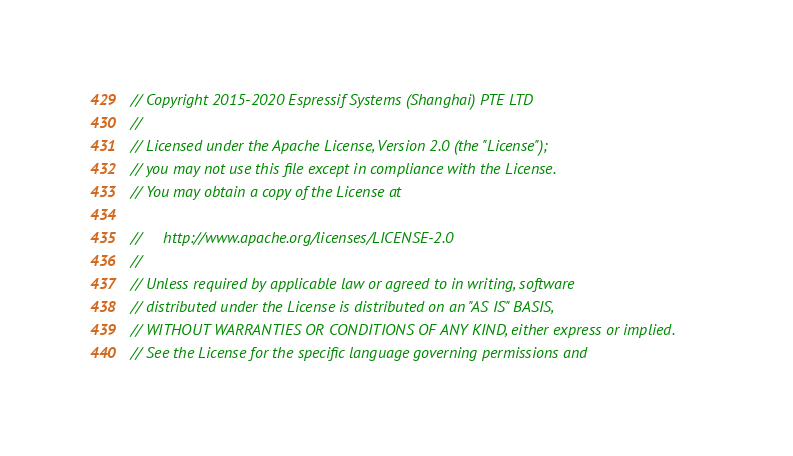Convert code to text. <code><loc_0><loc_0><loc_500><loc_500><_C_>// Copyright 2015-2020 Espressif Systems (Shanghai) PTE LTD
//
// Licensed under the Apache License, Version 2.0 (the "License");
// you may not use this file except in compliance with the License.
// You may obtain a copy of the License at

//     http://www.apache.org/licenses/LICENSE-2.0
//
// Unless required by applicable law or agreed to in writing, software
// distributed under the License is distributed on an "AS IS" BASIS,
// WITHOUT WARRANTIES OR CONDITIONS OF ANY KIND, either express or implied.
// See the License for the specific language governing permissions and</code> 